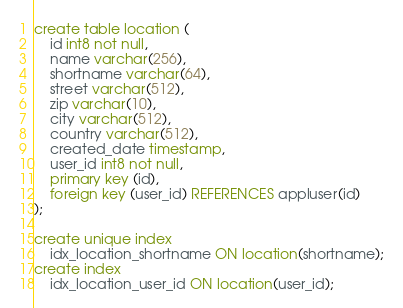Convert code to text. <code><loc_0><loc_0><loc_500><loc_500><_SQL_>create table location (
    id int8 not null,
    name varchar(256),
    shortname varchar(64),
    street varchar(512),
    zip varchar(10),
    city varchar(512),
    country varchar(512),
    created_date timestamp,
    user_id int8 not null,
    primary key (id),
    foreign key (user_id) REFERENCES appluser(id)
);

create unique index
    idx_location_shortname ON location(shortname);
create index
    idx_location_user_id ON location(user_id);
</code> 